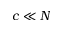Convert formula to latex. <formula><loc_0><loc_0><loc_500><loc_500>c \ll N</formula> 